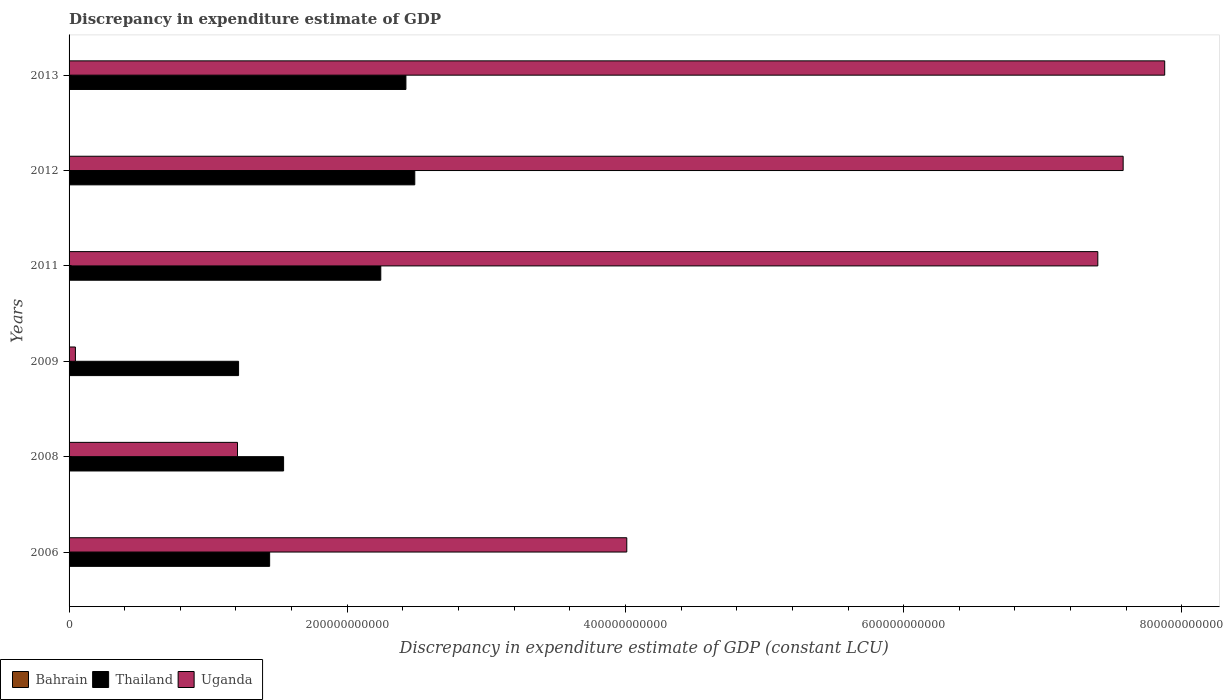Are the number of bars per tick equal to the number of legend labels?
Make the answer very short. Yes. Are the number of bars on each tick of the Y-axis equal?
Make the answer very short. Yes. What is the label of the 5th group of bars from the top?
Make the answer very short. 2008. In how many cases, is the number of bars for a given year not equal to the number of legend labels?
Your answer should be very brief. 0. What is the discrepancy in expenditure estimate of GDP in Uganda in 2011?
Provide a succinct answer. 7.40e+11. Across all years, what is the maximum discrepancy in expenditure estimate of GDP in Uganda?
Your answer should be compact. 7.88e+11. Across all years, what is the minimum discrepancy in expenditure estimate of GDP in Uganda?
Provide a succinct answer. 4.56e+09. In which year was the discrepancy in expenditure estimate of GDP in Bahrain maximum?
Offer a very short reply. 2013. What is the total discrepancy in expenditure estimate of GDP in Uganda in the graph?
Provide a succinct answer. 2.81e+12. What is the difference between the discrepancy in expenditure estimate of GDP in Bahrain in 2009 and that in 2012?
Your answer should be very brief. -1.50e+05. What is the difference between the discrepancy in expenditure estimate of GDP in Bahrain in 2011 and the discrepancy in expenditure estimate of GDP in Thailand in 2008?
Your answer should be compact. -1.54e+11. What is the average discrepancy in expenditure estimate of GDP in Thailand per year?
Make the answer very short. 1.89e+11. In the year 2012, what is the difference between the discrepancy in expenditure estimate of GDP in Uganda and discrepancy in expenditure estimate of GDP in Thailand?
Your response must be concise. 5.09e+11. What is the ratio of the discrepancy in expenditure estimate of GDP in Thailand in 2008 to that in 2011?
Your answer should be compact. 0.69. Is the discrepancy in expenditure estimate of GDP in Bahrain in 2008 less than that in 2009?
Keep it short and to the point. No. Is the difference between the discrepancy in expenditure estimate of GDP in Uganda in 2008 and 2013 greater than the difference between the discrepancy in expenditure estimate of GDP in Thailand in 2008 and 2013?
Offer a very short reply. No. What is the difference between the highest and the second highest discrepancy in expenditure estimate of GDP in Thailand?
Offer a very short reply. 6.37e+09. What is the difference between the highest and the lowest discrepancy in expenditure estimate of GDP in Uganda?
Offer a very short reply. 7.83e+11. In how many years, is the discrepancy in expenditure estimate of GDP in Uganda greater than the average discrepancy in expenditure estimate of GDP in Uganda taken over all years?
Your answer should be compact. 3. Is the sum of the discrepancy in expenditure estimate of GDP in Thailand in 2009 and 2011 greater than the maximum discrepancy in expenditure estimate of GDP in Uganda across all years?
Keep it short and to the point. No. What does the 1st bar from the top in 2011 represents?
Provide a short and direct response. Uganda. What does the 2nd bar from the bottom in 2006 represents?
Your answer should be very brief. Thailand. Is it the case that in every year, the sum of the discrepancy in expenditure estimate of GDP in Uganda and discrepancy in expenditure estimate of GDP in Thailand is greater than the discrepancy in expenditure estimate of GDP in Bahrain?
Keep it short and to the point. Yes. Are all the bars in the graph horizontal?
Keep it short and to the point. Yes. What is the difference between two consecutive major ticks on the X-axis?
Offer a very short reply. 2.00e+11. How many legend labels are there?
Your response must be concise. 3. How are the legend labels stacked?
Your answer should be compact. Horizontal. What is the title of the graph?
Offer a terse response. Discrepancy in expenditure estimate of GDP. Does "Nepal" appear as one of the legend labels in the graph?
Provide a short and direct response. No. What is the label or title of the X-axis?
Provide a succinct answer. Discrepancy in expenditure estimate of GDP (constant LCU). What is the label or title of the Y-axis?
Give a very brief answer. Years. What is the Discrepancy in expenditure estimate of GDP (constant LCU) of Thailand in 2006?
Your answer should be very brief. 1.44e+11. What is the Discrepancy in expenditure estimate of GDP (constant LCU) of Uganda in 2006?
Give a very brief answer. 4.01e+11. What is the Discrepancy in expenditure estimate of GDP (constant LCU) of Bahrain in 2008?
Your response must be concise. 8.30e+05. What is the Discrepancy in expenditure estimate of GDP (constant LCU) of Thailand in 2008?
Give a very brief answer. 1.54e+11. What is the Discrepancy in expenditure estimate of GDP (constant LCU) of Uganda in 2008?
Offer a terse response. 1.21e+11. What is the Discrepancy in expenditure estimate of GDP (constant LCU) in Thailand in 2009?
Your response must be concise. 1.22e+11. What is the Discrepancy in expenditure estimate of GDP (constant LCU) in Uganda in 2009?
Your response must be concise. 4.56e+09. What is the Discrepancy in expenditure estimate of GDP (constant LCU) of Bahrain in 2011?
Your answer should be very brief. 5.00e+04. What is the Discrepancy in expenditure estimate of GDP (constant LCU) of Thailand in 2011?
Your response must be concise. 2.24e+11. What is the Discrepancy in expenditure estimate of GDP (constant LCU) in Uganda in 2011?
Offer a very short reply. 7.40e+11. What is the Discrepancy in expenditure estimate of GDP (constant LCU) of Thailand in 2012?
Make the answer very short. 2.49e+11. What is the Discrepancy in expenditure estimate of GDP (constant LCU) in Uganda in 2012?
Give a very brief answer. 7.58e+11. What is the Discrepancy in expenditure estimate of GDP (constant LCU) in Bahrain in 2013?
Provide a succinct answer. 1.00e+06. What is the Discrepancy in expenditure estimate of GDP (constant LCU) in Thailand in 2013?
Your response must be concise. 2.42e+11. What is the Discrepancy in expenditure estimate of GDP (constant LCU) of Uganda in 2013?
Provide a short and direct response. 7.88e+11. Across all years, what is the maximum Discrepancy in expenditure estimate of GDP (constant LCU) of Bahrain?
Your answer should be compact. 1.00e+06. Across all years, what is the maximum Discrepancy in expenditure estimate of GDP (constant LCU) of Thailand?
Offer a very short reply. 2.49e+11. Across all years, what is the maximum Discrepancy in expenditure estimate of GDP (constant LCU) of Uganda?
Ensure brevity in your answer.  7.88e+11. Across all years, what is the minimum Discrepancy in expenditure estimate of GDP (constant LCU) of Bahrain?
Your answer should be compact. 10000. Across all years, what is the minimum Discrepancy in expenditure estimate of GDP (constant LCU) of Thailand?
Your answer should be very brief. 1.22e+11. Across all years, what is the minimum Discrepancy in expenditure estimate of GDP (constant LCU) in Uganda?
Your answer should be very brief. 4.56e+09. What is the total Discrepancy in expenditure estimate of GDP (constant LCU) in Bahrain in the graph?
Your response must be concise. 2.74e+06. What is the total Discrepancy in expenditure estimate of GDP (constant LCU) of Thailand in the graph?
Make the answer very short. 1.14e+12. What is the total Discrepancy in expenditure estimate of GDP (constant LCU) in Uganda in the graph?
Your answer should be very brief. 2.81e+12. What is the difference between the Discrepancy in expenditure estimate of GDP (constant LCU) of Bahrain in 2006 and that in 2008?
Provide a succinct answer. -8.20e+05. What is the difference between the Discrepancy in expenditure estimate of GDP (constant LCU) in Thailand in 2006 and that in 2008?
Offer a terse response. -1.00e+1. What is the difference between the Discrepancy in expenditure estimate of GDP (constant LCU) in Uganda in 2006 and that in 2008?
Give a very brief answer. 2.80e+11. What is the difference between the Discrepancy in expenditure estimate of GDP (constant LCU) of Thailand in 2006 and that in 2009?
Your answer should be very brief. 2.23e+1. What is the difference between the Discrepancy in expenditure estimate of GDP (constant LCU) in Uganda in 2006 and that in 2009?
Provide a succinct answer. 3.96e+11. What is the difference between the Discrepancy in expenditure estimate of GDP (constant LCU) in Bahrain in 2006 and that in 2011?
Ensure brevity in your answer.  -4.00e+04. What is the difference between the Discrepancy in expenditure estimate of GDP (constant LCU) in Thailand in 2006 and that in 2011?
Make the answer very short. -7.99e+1. What is the difference between the Discrepancy in expenditure estimate of GDP (constant LCU) of Uganda in 2006 and that in 2011?
Give a very brief answer. -3.39e+11. What is the difference between the Discrepancy in expenditure estimate of GDP (constant LCU) in Bahrain in 2006 and that in 2012?
Give a very brief answer. -4.90e+05. What is the difference between the Discrepancy in expenditure estimate of GDP (constant LCU) of Thailand in 2006 and that in 2012?
Your answer should be very brief. -1.04e+11. What is the difference between the Discrepancy in expenditure estimate of GDP (constant LCU) in Uganda in 2006 and that in 2012?
Offer a very short reply. -3.57e+11. What is the difference between the Discrepancy in expenditure estimate of GDP (constant LCU) of Bahrain in 2006 and that in 2013?
Your response must be concise. -9.90e+05. What is the difference between the Discrepancy in expenditure estimate of GDP (constant LCU) in Thailand in 2006 and that in 2013?
Offer a terse response. -9.80e+1. What is the difference between the Discrepancy in expenditure estimate of GDP (constant LCU) of Uganda in 2006 and that in 2013?
Make the answer very short. -3.87e+11. What is the difference between the Discrepancy in expenditure estimate of GDP (constant LCU) of Thailand in 2008 and that in 2009?
Keep it short and to the point. 3.24e+1. What is the difference between the Discrepancy in expenditure estimate of GDP (constant LCU) of Uganda in 2008 and that in 2009?
Your answer should be very brief. 1.17e+11. What is the difference between the Discrepancy in expenditure estimate of GDP (constant LCU) of Bahrain in 2008 and that in 2011?
Provide a succinct answer. 7.80e+05. What is the difference between the Discrepancy in expenditure estimate of GDP (constant LCU) of Thailand in 2008 and that in 2011?
Your answer should be compact. -6.99e+1. What is the difference between the Discrepancy in expenditure estimate of GDP (constant LCU) of Uganda in 2008 and that in 2011?
Provide a short and direct response. -6.19e+11. What is the difference between the Discrepancy in expenditure estimate of GDP (constant LCU) in Bahrain in 2008 and that in 2012?
Ensure brevity in your answer.  3.30e+05. What is the difference between the Discrepancy in expenditure estimate of GDP (constant LCU) of Thailand in 2008 and that in 2012?
Give a very brief answer. -9.43e+1. What is the difference between the Discrepancy in expenditure estimate of GDP (constant LCU) in Uganda in 2008 and that in 2012?
Keep it short and to the point. -6.37e+11. What is the difference between the Discrepancy in expenditure estimate of GDP (constant LCU) in Thailand in 2008 and that in 2013?
Provide a succinct answer. -8.79e+1. What is the difference between the Discrepancy in expenditure estimate of GDP (constant LCU) of Uganda in 2008 and that in 2013?
Your answer should be very brief. -6.67e+11. What is the difference between the Discrepancy in expenditure estimate of GDP (constant LCU) of Thailand in 2009 and that in 2011?
Provide a succinct answer. -1.02e+11. What is the difference between the Discrepancy in expenditure estimate of GDP (constant LCU) in Uganda in 2009 and that in 2011?
Your answer should be compact. -7.35e+11. What is the difference between the Discrepancy in expenditure estimate of GDP (constant LCU) of Thailand in 2009 and that in 2012?
Provide a short and direct response. -1.27e+11. What is the difference between the Discrepancy in expenditure estimate of GDP (constant LCU) in Uganda in 2009 and that in 2012?
Keep it short and to the point. -7.53e+11. What is the difference between the Discrepancy in expenditure estimate of GDP (constant LCU) in Bahrain in 2009 and that in 2013?
Give a very brief answer. -6.50e+05. What is the difference between the Discrepancy in expenditure estimate of GDP (constant LCU) of Thailand in 2009 and that in 2013?
Your response must be concise. -1.20e+11. What is the difference between the Discrepancy in expenditure estimate of GDP (constant LCU) of Uganda in 2009 and that in 2013?
Provide a short and direct response. -7.83e+11. What is the difference between the Discrepancy in expenditure estimate of GDP (constant LCU) in Bahrain in 2011 and that in 2012?
Your answer should be compact. -4.50e+05. What is the difference between the Discrepancy in expenditure estimate of GDP (constant LCU) in Thailand in 2011 and that in 2012?
Offer a terse response. -2.44e+1. What is the difference between the Discrepancy in expenditure estimate of GDP (constant LCU) in Uganda in 2011 and that in 2012?
Your response must be concise. -1.82e+1. What is the difference between the Discrepancy in expenditure estimate of GDP (constant LCU) in Bahrain in 2011 and that in 2013?
Your answer should be very brief. -9.50e+05. What is the difference between the Discrepancy in expenditure estimate of GDP (constant LCU) of Thailand in 2011 and that in 2013?
Your answer should be compact. -1.81e+1. What is the difference between the Discrepancy in expenditure estimate of GDP (constant LCU) of Uganda in 2011 and that in 2013?
Provide a succinct answer. -4.81e+1. What is the difference between the Discrepancy in expenditure estimate of GDP (constant LCU) in Bahrain in 2012 and that in 2013?
Make the answer very short. -5.00e+05. What is the difference between the Discrepancy in expenditure estimate of GDP (constant LCU) in Thailand in 2012 and that in 2013?
Provide a short and direct response. 6.37e+09. What is the difference between the Discrepancy in expenditure estimate of GDP (constant LCU) of Uganda in 2012 and that in 2013?
Provide a succinct answer. -2.99e+1. What is the difference between the Discrepancy in expenditure estimate of GDP (constant LCU) of Bahrain in 2006 and the Discrepancy in expenditure estimate of GDP (constant LCU) of Thailand in 2008?
Provide a short and direct response. -1.54e+11. What is the difference between the Discrepancy in expenditure estimate of GDP (constant LCU) in Bahrain in 2006 and the Discrepancy in expenditure estimate of GDP (constant LCU) in Uganda in 2008?
Offer a terse response. -1.21e+11. What is the difference between the Discrepancy in expenditure estimate of GDP (constant LCU) in Thailand in 2006 and the Discrepancy in expenditure estimate of GDP (constant LCU) in Uganda in 2008?
Keep it short and to the point. 2.31e+1. What is the difference between the Discrepancy in expenditure estimate of GDP (constant LCU) in Bahrain in 2006 and the Discrepancy in expenditure estimate of GDP (constant LCU) in Thailand in 2009?
Keep it short and to the point. -1.22e+11. What is the difference between the Discrepancy in expenditure estimate of GDP (constant LCU) of Bahrain in 2006 and the Discrepancy in expenditure estimate of GDP (constant LCU) of Uganda in 2009?
Your response must be concise. -4.56e+09. What is the difference between the Discrepancy in expenditure estimate of GDP (constant LCU) of Thailand in 2006 and the Discrepancy in expenditure estimate of GDP (constant LCU) of Uganda in 2009?
Provide a succinct answer. 1.40e+11. What is the difference between the Discrepancy in expenditure estimate of GDP (constant LCU) in Bahrain in 2006 and the Discrepancy in expenditure estimate of GDP (constant LCU) in Thailand in 2011?
Offer a terse response. -2.24e+11. What is the difference between the Discrepancy in expenditure estimate of GDP (constant LCU) of Bahrain in 2006 and the Discrepancy in expenditure estimate of GDP (constant LCU) of Uganda in 2011?
Your answer should be compact. -7.40e+11. What is the difference between the Discrepancy in expenditure estimate of GDP (constant LCU) in Thailand in 2006 and the Discrepancy in expenditure estimate of GDP (constant LCU) in Uganda in 2011?
Give a very brief answer. -5.95e+11. What is the difference between the Discrepancy in expenditure estimate of GDP (constant LCU) in Bahrain in 2006 and the Discrepancy in expenditure estimate of GDP (constant LCU) in Thailand in 2012?
Your response must be concise. -2.49e+11. What is the difference between the Discrepancy in expenditure estimate of GDP (constant LCU) of Bahrain in 2006 and the Discrepancy in expenditure estimate of GDP (constant LCU) of Uganda in 2012?
Your answer should be very brief. -7.58e+11. What is the difference between the Discrepancy in expenditure estimate of GDP (constant LCU) of Thailand in 2006 and the Discrepancy in expenditure estimate of GDP (constant LCU) of Uganda in 2012?
Make the answer very short. -6.14e+11. What is the difference between the Discrepancy in expenditure estimate of GDP (constant LCU) in Bahrain in 2006 and the Discrepancy in expenditure estimate of GDP (constant LCU) in Thailand in 2013?
Ensure brevity in your answer.  -2.42e+11. What is the difference between the Discrepancy in expenditure estimate of GDP (constant LCU) in Bahrain in 2006 and the Discrepancy in expenditure estimate of GDP (constant LCU) in Uganda in 2013?
Give a very brief answer. -7.88e+11. What is the difference between the Discrepancy in expenditure estimate of GDP (constant LCU) in Thailand in 2006 and the Discrepancy in expenditure estimate of GDP (constant LCU) in Uganda in 2013?
Your response must be concise. -6.43e+11. What is the difference between the Discrepancy in expenditure estimate of GDP (constant LCU) in Bahrain in 2008 and the Discrepancy in expenditure estimate of GDP (constant LCU) in Thailand in 2009?
Offer a very short reply. -1.22e+11. What is the difference between the Discrepancy in expenditure estimate of GDP (constant LCU) in Bahrain in 2008 and the Discrepancy in expenditure estimate of GDP (constant LCU) in Uganda in 2009?
Keep it short and to the point. -4.56e+09. What is the difference between the Discrepancy in expenditure estimate of GDP (constant LCU) of Thailand in 2008 and the Discrepancy in expenditure estimate of GDP (constant LCU) of Uganda in 2009?
Keep it short and to the point. 1.50e+11. What is the difference between the Discrepancy in expenditure estimate of GDP (constant LCU) in Bahrain in 2008 and the Discrepancy in expenditure estimate of GDP (constant LCU) in Thailand in 2011?
Make the answer very short. -2.24e+11. What is the difference between the Discrepancy in expenditure estimate of GDP (constant LCU) in Bahrain in 2008 and the Discrepancy in expenditure estimate of GDP (constant LCU) in Uganda in 2011?
Keep it short and to the point. -7.40e+11. What is the difference between the Discrepancy in expenditure estimate of GDP (constant LCU) of Thailand in 2008 and the Discrepancy in expenditure estimate of GDP (constant LCU) of Uganda in 2011?
Provide a short and direct response. -5.85e+11. What is the difference between the Discrepancy in expenditure estimate of GDP (constant LCU) of Bahrain in 2008 and the Discrepancy in expenditure estimate of GDP (constant LCU) of Thailand in 2012?
Offer a very short reply. -2.49e+11. What is the difference between the Discrepancy in expenditure estimate of GDP (constant LCU) of Bahrain in 2008 and the Discrepancy in expenditure estimate of GDP (constant LCU) of Uganda in 2012?
Make the answer very short. -7.58e+11. What is the difference between the Discrepancy in expenditure estimate of GDP (constant LCU) of Thailand in 2008 and the Discrepancy in expenditure estimate of GDP (constant LCU) of Uganda in 2012?
Keep it short and to the point. -6.04e+11. What is the difference between the Discrepancy in expenditure estimate of GDP (constant LCU) of Bahrain in 2008 and the Discrepancy in expenditure estimate of GDP (constant LCU) of Thailand in 2013?
Keep it short and to the point. -2.42e+11. What is the difference between the Discrepancy in expenditure estimate of GDP (constant LCU) of Bahrain in 2008 and the Discrepancy in expenditure estimate of GDP (constant LCU) of Uganda in 2013?
Provide a short and direct response. -7.88e+11. What is the difference between the Discrepancy in expenditure estimate of GDP (constant LCU) in Thailand in 2008 and the Discrepancy in expenditure estimate of GDP (constant LCU) in Uganda in 2013?
Offer a terse response. -6.33e+11. What is the difference between the Discrepancy in expenditure estimate of GDP (constant LCU) of Bahrain in 2009 and the Discrepancy in expenditure estimate of GDP (constant LCU) of Thailand in 2011?
Provide a short and direct response. -2.24e+11. What is the difference between the Discrepancy in expenditure estimate of GDP (constant LCU) in Bahrain in 2009 and the Discrepancy in expenditure estimate of GDP (constant LCU) in Uganda in 2011?
Keep it short and to the point. -7.40e+11. What is the difference between the Discrepancy in expenditure estimate of GDP (constant LCU) of Thailand in 2009 and the Discrepancy in expenditure estimate of GDP (constant LCU) of Uganda in 2011?
Make the answer very short. -6.18e+11. What is the difference between the Discrepancy in expenditure estimate of GDP (constant LCU) in Bahrain in 2009 and the Discrepancy in expenditure estimate of GDP (constant LCU) in Thailand in 2012?
Offer a very short reply. -2.49e+11. What is the difference between the Discrepancy in expenditure estimate of GDP (constant LCU) of Bahrain in 2009 and the Discrepancy in expenditure estimate of GDP (constant LCU) of Uganda in 2012?
Keep it short and to the point. -7.58e+11. What is the difference between the Discrepancy in expenditure estimate of GDP (constant LCU) in Thailand in 2009 and the Discrepancy in expenditure estimate of GDP (constant LCU) in Uganda in 2012?
Your answer should be very brief. -6.36e+11. What is the difference between the Discrepancy in expenditure estimate of GDP (constant LCU) of Bahrain in 2009 and the Discrepancy in expenditure estimate of GDP (constant LCU) of Thailand in 2013?
Offer a terse response. -2.42e+11. What is the difference between the Discrepancy in expenditure estimate of GDP (constant LCU) of Bahrain in 2009 and the Discrepancy in expenditure estimate of GDP (constant LCU) of Uganda in 2013?
Offer a terse response. -7.88e+11. What is the difference between the Discrepancy in expenditure estimate of GDP (constant LCU) in Thailand in 2009 and the Discrepancy in expenditure estimate of GDP (constant LCU) in Uganda in 2013?
Offer a very short reply. -6.66e+11. What is the difference between the Discrepancy in expenditure estimate of GDP (constant LCU) of Bahrain in 2011 and the Discrepancy in expenditure estimate of GDP (constant LCU) of Thailand in 2012?
Your answer should be very brief. -2.49e+11. What is the difference between the Discrepancy in expenditure estimate of GDP (constant LCU) of Bahrain in 2011 and the Discrepancy in expenditure estimate of GDP (constant LCU) of Uganda in 2012?
Your answer should be very brief. -7.58e+11. What is the difference between the Discrepancy in expenditure estimate of GDP (constant LCU) in Thailand in 2011 and the Discrepancy in expenditure estimate of GDP (constant LCU) in Uganda in 2012?
Provide a short and direct response. -5.34e+11. What is the difference between the Discrepancy in expenditure estimate of GDP (constant LCU) in Bahrain in 2011 and the Discrepancy in expenditure estimate of GDP (constant LCU) in Thailand in 2013?
Make the answer very short. -2.42e+11. What is the difference between the Discrepancy in expenditure estimate of GDP (constant LCU) of Bahrain in 2011 and the Discrepancy in expenditure estimate of GDP (constant LCU) of Uganda in 2013?
Your answer should be very brief. -7.88e+11. What is the difference between the Discrepancy in expenditure estimate of GDP (constant LCU) in Thailand in 2011 and the Discrepancy in expenditure estimate of GDP (constant LCU) in Uganda in 2013?
Provide a succinct answer. -5.64e+11. What is the difference between the Discrepancy in expenditure estimate of GDP (constant LCU) of Bahrain in 2012 and the Discrepancy in expenditure estimate of GDP (constant LCU) of Thailand in 2013?
Offer a terse response. -2.42e+11. What is the difference between the Discrepancy in expenditure estimate of GDP (constant LCU) of Bahrain in 2012 and the Discrepancy in expenditure estimate of GDP (constant LCU) of Uganda in 2013?
Your response must be concise. -7.88e+11. What is the difference between the Discrepancy in expenditure estimate of GDP (constant LCU) in Thailand in 2012 and the Discrepancy in expenditure estimate of GDP (constant LCU) in Uganda in 2013?
Ensure brevity in your answer.  -5.39e+11. What is the average Discrepancy in expenditure estimate of GDP (constant LCU) of Bahrain per year?
Keep it short and to the point. 4.57e+05. What is the average Discrepancy in expenditure estimate of GDP (constant LCU) of Thailand per year?
Your answer should be compact. 1.89e+11. What is the average Discrepancy in expenditure estimate of GDP (constant LCU) of Uganda per year?
Make the answer very short. 4.69e+11. In the year 2006, what is the difference between the Discrepancy in expenditure estimate of GDP (constant LCU) of Bahrain and Discrepancy in expenditure estimate of GDP (constant LCU) of Thailand?
Ensure brevity in your answer.  -1.44e+11. In the year 2006, what is the difference between the Discrepancy in expenditure estimate of GDP (constant LCU) of Bahrain and Discrepancy in expenditure estimate of GDP (constant LCU) of Uganda?
Provide a short and direct response. -4.01e+11. In the year 2006, what is the difference between the Discrepancy in expenditure estimate of GDP (constant LCU) of Thailand and Discrepancy in expenditure estimate of GDP (constant LCU) of Uganda?
Provide a succinct answer. -2.57e+11. In the year 2008, what is the difference between the Discrepancy in expenditure estimate of GDP (constant LCU) of Bahrain and Discrepancy in expenditure estimate of GDP (constant LCU) of Thailand?
Offer a terse response. -1.54e+11. In the year 2008, what is the difference between the Discrepancy in expenditure estimate of GDP (constant LCU) of Bahrain and Discrepancy in expenditure estimate of GDP (constant LCU) of Uganda?
Ensure brevity in your answer.  -1.21e+11. In the year 2008, what is the difference between the Discrepancy in expenditure estimate of GDP (constant LCU) in Thailand and Discrepancy in expenditure estimate of GDP (constant LCU) in Uganda?
Make the answer very short. 3.31e+1. In the year 2009, what is the difference between the Discrepancy in expenditure estimate of GDP (constant LCU) of Bahrain and Discrepancy in expenditure estimate of GDP (constant LCU) of Thailand?
Offer a very short reply. -1.22e+11. In the year 2009, what is the difference between the Discrepancy in expenditure estimate of GDP (constant LCU) in Bahrain and Discrepancy in expenditure estimate of GDP (constant LCU) in Uganda?
Make the answer very short. -4.56e+09. In the year 2009, what is the difference between the Discrepancy in expenditure estimate of GDP (constant LCU) of Thailand and Discrepancy in expenditure estimate of GDP (constant LCU) of Uganda?
Your answer should be very brief. 1.17e+11. In the year 2011, what is the difference between the Discrepancy in expenditure estimate of GDP (constant LCU) in Bahrain and Discrepancy in expenditure estimate of GDP (constant LCU) in Thailand?
Your answer should be compact. -2.24e+11. In the year 2011, what is the difference between the Discrepancy in expenditure estimate of GDP (constant LCU) of Bahrain and Discrepancy in expenditure estimate of GDP (constant LCU) of Uganda?
Keep it short and to the point. -7.40e+11. In the year 2011, what is the difference between the Discrepancy in expenditure estimate of GDP (constant LCU) in Thailand and Discrepancy in expenditure estimate of GDP (constant LCU) in Uganda?
Offer a very short reply. -5.15e+11. In the year 2012, what is the difference between the Discrepancy in expenditure estimate of GDP (constant LCU) in Bahrain and Discrepancy in expenditure estimate of GDP (constant LCU) in Thailand?
Keep it short and to the point. -2.49e+11. In the year 2012, what is the difference between the Discrepancy in expenditure estimate of GDP (constant LCU) of Bahrain and Discrepancy in expenditure estimate of GDP (constant LCU) of Uganda?
Your response must be concise. -7.58e+11. In the year 2012, what is the difference between the Discrepancy in expenditure estimate of GDP (constant LCU) of Thailand and Discrepancy in expenditure estimate of GDP (constant LCU) of Uganda?
Provide a short and direct response. -5.09e+11. In the year 2013, what is the difference between the Discrepancy in expenditure estimate of GDP (constant LCU) of Bahrain and Discrepancy in expenditure estimate of GDP (constant LCU) of Thailand?
Make the answer very short. -2.42e+11. In the year 2013, what is the difference between the Discrepancy in expenditure estimate of GDP (constant LCU) in Bahrain and Discrepancy in expenditure estimate of GDP (constant LCU) in Uganda?
Your answer should be compact. -7.88e+11. In the year 2013, what is the difference between the Discrepancy in expenditure estimate of GDP (constant LCU) in Thailand and Discrepancy in expenditure estimate of GDP (constant LCU) in Uganda?
Offer a terse response. -5.46e+11. What is the ratio of the Discrepancy in expenditure estimate of GDP (constant LCU) of Bahrain in 2006 to that in 2008?
Provide a short and direct response. 0.01. What is the ratio of the Discrepancy in expenditure estimate of GDP (constant LCU) of Thailand in 2006 to that in 2008?
Your answer should be compact. 0.94. What is the ratio of the Discrepancy in expenditure estimate of GDP (constant LCU) in Uganda in 2006 to that in 2008?
Keep it short and to the point. 3.31. What is the ratio of the Discrepancy in expenditure estimate of GDP (constant LCU) of Bahrain in 2006 to that in 2009?
Give a very brief answer. 0.03. What is the ratio of the Discrepancy in expenditure estimate of GDP (constant LCU) in Thailand in 2006 to that in 2009?
Provide a short and direct response. 1.18. What is the ratio of the Discrepancy in expenditure estimate of GDP (constant LCU) in Uganda in 2006 to that in 2009?
Make the answer very short. 87.95. What is the ratio of the Discrepancy in expenditure estimate of GDP (constant LCU) in Thailand in 2006 to that in 2011?
Make the answer very short. 0.64. What is the ratio of the Discrepancy in expenditure estimate of GDP (constant LCU) in Uganda in 2006 to that in 2011?
Provide a succinct answer. 0.54. What is the ratio of the Discrepancy in expenditure estimate of GDP (constant LCU) of Bahrain in 2006 to that in 2012?
Your answer should be compact. 0.02. What is the ratio of the Discrepancy in expenditure estimate of GDP (constant LCU) in Thailand in 2006 to that in 2012?
Make the answer very short. 0.58. What is the ratio of the Discrepancy in expenditure estimate of GDP (constant LCU) in Uganda in 2006 to that in 2012?
Give a very brief answer. 0.53. What is the ratio of the Discrepancy in expenditure estimate of GDP (constant LCU) of Bahrain in 2006 to that in 2013?
Your answer should be very brief. 0.01. What is the ratio of the Discrepancy in expenditure estimate of GDP (constant LCU) of Thailand in 2006 to that in 2013?
Your response must be concise. 0.6. What is the ratio of the Discrepancy in expenditure estimate of GDP (constant LCU) of Uganda in 2006 to that in 2013?
Offer a very short reply. 0.51. What is the ratio of the Discrepancy in expenditure estimate of GDP (constant LCU) in Bahrain in 2008 to that in 2009?
Your answer should be compact. 2.37. What is the ratio of the Discrepancy in expenditure estimate of GDP (constant LCU) of Thailand in 2008 to that in 2009?
Your response must be concise. 1.27. What is the ratio of the Discrepancy in expenditure estimate of GDP (constant LCU) of Uganda in 2008 to that in 2009?
Ensure brevity in your answer.  26.56. What is the ratio of the Discrepancy in expenditure estimate of GDP (constant LCU) in Thailand in 2008 to that in 2011?
Make the answer very short. 0.69. What is the ratio of the Discrepancy in expenditure estimate of GDP (constant LCU) of Uganda in 2008 to that in 2011?
Provide a short and direct response. 0.16. What is the ratio of the Discrepancy in expenditure estimate of GDP (constant LCU) in Bahrain in 2008 to that in 2012?
Offer a terse response. 1.66. What is the ratio of the Discrepancy in expenditure estimate of GDP (constant LCU) of Thailand in 2008 to that in 2012?
Provide a short and direct response. 0.62. What is the ratio of the Discrepancy in expenditure estimate of GDP (constant LCU) of Uganda in 2008 to that in 2012?
Provide a succinct answer. 0.16. What is the ratio of the Discrepancy in expenditure estimate of GDP (constant LCU) of Bahrain in 2008 to that in 2013?
Your response must be concise. 0.83. What is the ratio of the Discrepancy in expenditure estimate of GDP (constant LCU) of Thailand in 2008 to that in 2013?
Your answer should be compact. 0.64. What is the ratio of the Discrepancy in expenditure estimate of GDP (constant LCU) in Uganda in 2008 to that in 2013?
Keep it short and to the point. 0.15. What is the ratio of the Discrepancy in expenditure estimate of GDP (constant LCU) in Thailand in 2009 to that in 2011?
Keep it short and to the point. 0.54. What is the ratio of the Discrepancy in expenditure estimate of GDP (constant LCU) in Uganda in 2009 to that in 2011?
Give a very brief answer. 0.01. What is the ratio of the Discrepancy in expenditure estimate of GDP (constant LCU) in Thailand in 2009 to that in 2012?
Provide a succinct answer. 0.49. What is the ratio of the Discrepancy in expenditure estimate of GDP (constant LCU) of Uganda in 2009 to that in 2012?
Make the answer very short. 0.01. What is the ratio of the Discrepancy in expenditure estimate of GDP (constant LCU) in Thailand in 2009 to that in 2013?
Make the answer very short. 0.5. What is the ratio of the Discrepancy in expenditure estimate of GDP (constant LCU) in Uganda in 2009 to that in 2013?
Keep it short and to the point. 0.01. What is the ratio of the Discrepancy in expenditure estimate of GDP (constant LCU) in Thailand in 2011 to that in 2012?
Provide a short and direct response. 0.9. What is the ratio of the Discrepancy in expenditure estimate of GDP (constant LCU) in Uganda in 2011 to that in 2012?
Give a very brief answer. 0.98. What is the ratio of the Discrepancy in expenditure estimate of GDP (constant LCU) of Thailand in 2011 to that in 2013?
Provide a short and direct response. 0.93. What is the ratio of the Discrepancy in expenditure estimate of GDP (constant LCU) of Uganda in 2011 to that in 2013?
Make the answer very short. 0.94. What is the ratio of the Discrepancy in expenditure estimate of GDP (constant LCU) of Thailand in 2012 to that in 2013?
Make the answer very short. 1.03. What is the ratio of the Discrepancy in expenditure estimate of GDP (constant LCU) in Uganda in 2012 to that in 2013?
Make the answer very short. 0.96. What is the difference between the highest and the second highest Discrepancy in expenditure estimate of GDP (constant LCU) in Bahrain?
Keep it short and to the point. 1.70e+05. What is the difference between the highest and the second highest Discrepancy in expenditure estimate of GDP (constant LCU) of Thailand?
Keep it short and to the point. 6.37e+09. What is the difference between the highest and the second highest Discrepancy in expenditure estimate of GDP (constant LCU) in Uganda?
Provide a succinct answer. 2.99e+1. What is the difference between the highest and the lowest Discrepancy in expenditure estimate of GDP (constant LCU) in Bahrain?
Ensure brevity in your answer.  9.90e+05. What is the difference between the highest and the lowest Discrepancy in expenditure estimate of GDP (constant LCU) in Thailand?
Your response must be concise. 1.27e+11. What is the difference between the highest and the lowest Discrepancy in expenditure estimate of GDP (constant LCU) in Uganda?
Make the answer very short. 7.83e+11. 